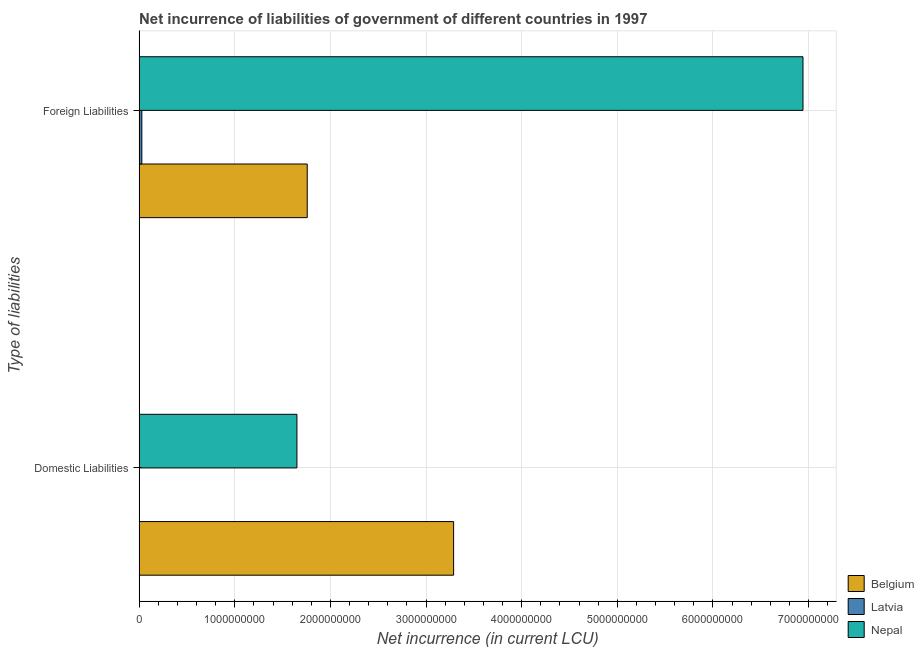How many different coloured bars are there?
Give a very brief answer. 3. Are the number of bars per tick equal to the number of legend labels?
Offer a terse response. No. Are the number of bars on each tick of the Y-axis equal?
Offer a very short reply. No. How many bars are there on the 1st tick from the top?
Offer a very short reply. 3. How many bars are there on the 1st tick from the bottom?
Offer a very short reply. 2. What is the label of the 1st group of bars from the top?
Provide a short and direct response. Foreign Liabilities. What is the net incurrence of domestic liabilities in Latvia?
Your answer should be very brief. 0. Across all countries, what is the maximum net incurrence of domestic liabilities?
Your answer should be very brief. 3.29e+09. Across all countries, what is the minimum net incurrence of domestic liabilities?
Your answer should be very brief. 0. In which country was the net incurrence of foreign liabilities maximum?
Provide a succinct answer. Nepal. What is the total net incurrence of foreign liabilities in the graph?
Provide a succinct answer. 8.73e+09. What is the difference between the net incurrence of domestic liabilities in Belgium and that in Nepal?
Give a very brief answer. 1.64e+09. What is the difference between the net incurrence of foreign liabilities in Nepal and the net incurrence of domestic liabilities in Latvia?
Your response must be concise. 6.94e+09. What is the average net incurrence of foreign liabilities per country?
Ensure brevity in your answer.  2.91e+09. What is the difference between the net incurrence of domestic liabilities and net incurrence of foreign liabilities in Nepal?
Make the answer very short. -5.29e+09. What is the ratio of the net incurrence of foreign liabilities in Nepal to that in Belgium?
Offer a terse response. 3.95. Is the net incurrence of foreign liabilities in Latvia less than that in Belgium?
Ensure brevity in your answer.  Yes. How many countries are there in the graph?
Keep it short and to the point. 3. Where does the legend appear in the graph?
Keep it short and to the point. Bottom right. What is the title of the graph?
Offer a terse response. Net incurrence of liabilities of government of different countries in 1997. Does "Bangladesh" appear as one of the legend labels in the graph?
Your answer should be very brief. No. What is the label or title of the X-axis?
Make the answer very short. Net incurrence (in current LCU). What is the label or title of the Y-axis?
Your answer should be very brief. Type of liabilities. What is the Net incurrence (in current LCU) of Belgium in Domestic Liabilities?
Ensure brevity in your answer.  3.29e+09. What is the Net incurrence (in current LCU) of Latvia in Domestic Liabilities?
Offer a very short reply. 0. What is the Net incurrence (in current LCU) of Nepal in Domestic Liabilities?
Provide a succinct answer. 1.65e+09. What is the Net incurrence (in current LCU) of Belgium in Foreign Liabilities?
Offer a terse response. 1.76e+09. What is the Net incurrence (in current LCU) of Latvia in Foreign Liabilities?
Offer a very short reply. 2.86e+07. What is the Net incurrence (in current LCU) in Nepal in Foreign Liabilities?
Ensure brevity in your answer.  6.94e+09. Across all Type of liabilities, what is the maximum Net incurrence (in current LCU) in Belgium?
Ensure brevity in your answer.  3.29e+09. Across all Type of liabilities, what is the maximum Net incurrence (in current LCU) in Latvia?
Your answer should be compact. 2.86e+07. Across all Type of liabilities, what is the maximum Net incurrence (in current LCU) of Nepal?
Your response must be concise. 6.94e+09. Across all Type of liabilities, what is the minimum Net incurrence (in current LCU) of Belgium?
Give a very brief answer. 1.76e+09. Across all Type of liabilities, what is the minimum Net incurrence (in current LCU) in Nepal?
Your response must be concise. 1.65e+09. What is the total Net incurrence (in current LCU) of Belgium in the graph?
Offer a terse response. 5.05e+09. What is the total Net incurrence (in current LCU) in Latvia in the graph?
Give a very brief answer. 2.86e+07. What is the total Net incurrence (in current LCU) in Nepal in the graph?
Offer a terse response. 8.59e+09. What is the difference between the Net incurrence (in current LCU) in Belgium in Domestic Liabilities and that in Foreign Liabilities?
Keep it short and to the point. 1.53e+09. What is the difference between the Net incurrence (in current LCU) of Nepal in Domestic Liabilities and that in Foreign Liabilities?
Provide a succinct answer. -5.29e+09. What is the difference between the Net incurrence (in current LCU) of Belgium in Domestic Liabilities and the Net incurrence (in current LCU) of Latvia in Foreign Liabilities?
Give a very brief answer. 3.26e+09. What is the difference between the Net incurrence (in current LCU) of Belgium in Domestic Liabilities and the Net incurrence (in current LCU) of Nepal in Foreign Liabilities?
Your answer should be compact. -3.65e+09. What is the average Net incurrence (in current LCU) in Belgium per Type of liabilities?
Make the answer very short. 2.52e+09. What is the average Net incurrence (in current LCU) in Latvia per Type of liabilities?
Provide a short and direct response. 1.43e+07. What is the average Net incurrence (in current LCU) in Nepal per Type of liabilities?
Your response must be concise. 4.30e+09. What is the difference between the Net incurrence (in current LCU) in Belgium and Net incurrence (in current LCU) in Nepal in Domestic Liabilities?
Ensure brevity in your answer.  1.64e+09. What is the difference between the Net incurrence (in current LCU) in Belgium and Net incurrence (in current LCU) in Latvia in Foreign Liabilities?
Give a very brief answer. 1.73e+09. What is the difference between the Net incurrence (in current LCU) of Belgium and Net incurrence (in current LCU) of Nepal in Foreign Liabilities?
Ensure brevity in your answer.  -5.18e+09. What is the difference between the Net incurrence (in current LCU) of Latvia and Net incurrence (in current LCU) of Nepal in Foreign Liabilities?
Offer a very short reply. -6.91e+09. What is the ratio of the Net incurrence (in current LCU) of Belgium in Domestic Liabilities to that in Foreign Liabilities?
Offer a very short reply. 1.87. What is the ratio of the Net incurrence (in current LCU) of Nepal in Domestic Liabilities to that in Foreign Liabilities?
Give a very brief answer. 0.24. What is the difference between the highest and the second highest Net incurrence (in current LCU) in Belgium?
Your response must be concise. 1.53e+09. What is the difference between the highest and the second highest Net incurrence (in current LCU) of Nepal?
Provide a short and direct response. 5.29e+09. What is the difference between the highest and the lowest Net incurrence (in current LCU) of Belgium?
Ensure brevity in your answer.  1.53e+09. What is the difference between the highest and the lowest Net incurrence (in current LCU) in Latvia?
Your answer should be compact. 2.86e+07. What is the difference between the highest and the lowest Net incurrence (in current LCU) of Nepal?
Your answer should be compact. 5.29e+09. 